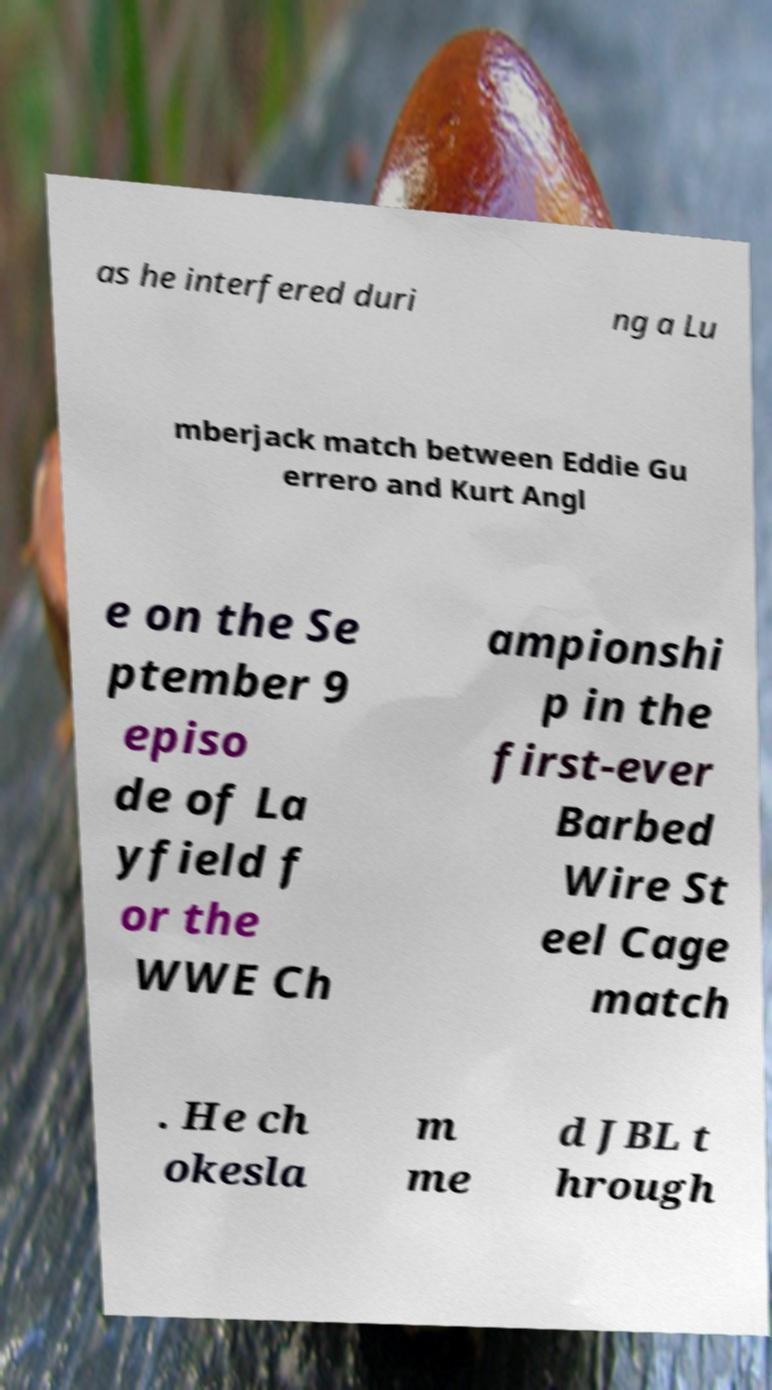For documentation purposes, I need the text within this image transcribed. Could you provide that? as he interfered duri ng a Lu mberjack match between Eddie Gu errero and Kurt Angl e on the Se ptember 9 episo de of La yfield f or the WWE Ch ampionshi p in the first-ever Barbed Wire St eel Cage match . He ch okesla m me d JBL t hrough 